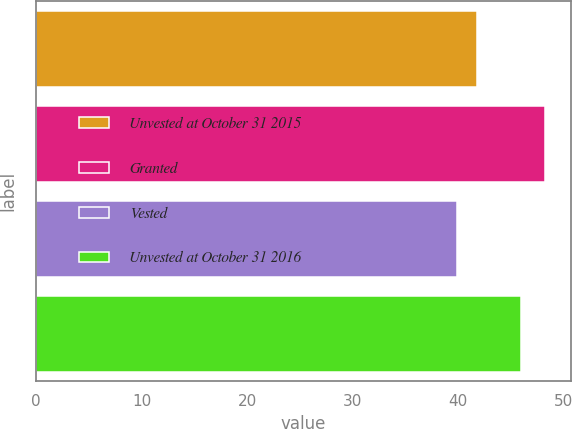<chart> <loc_0><loc_0><loc_500><loc_500><bar_chart><fcel>Unvested at October 31 2015<fcel>Granted<fcel>Vested<fcel>Unvested at October 31 2016<nl><fcel>41.82<fcel>48.27<fcel>39.94<fcel>45.97<nl></chart> 